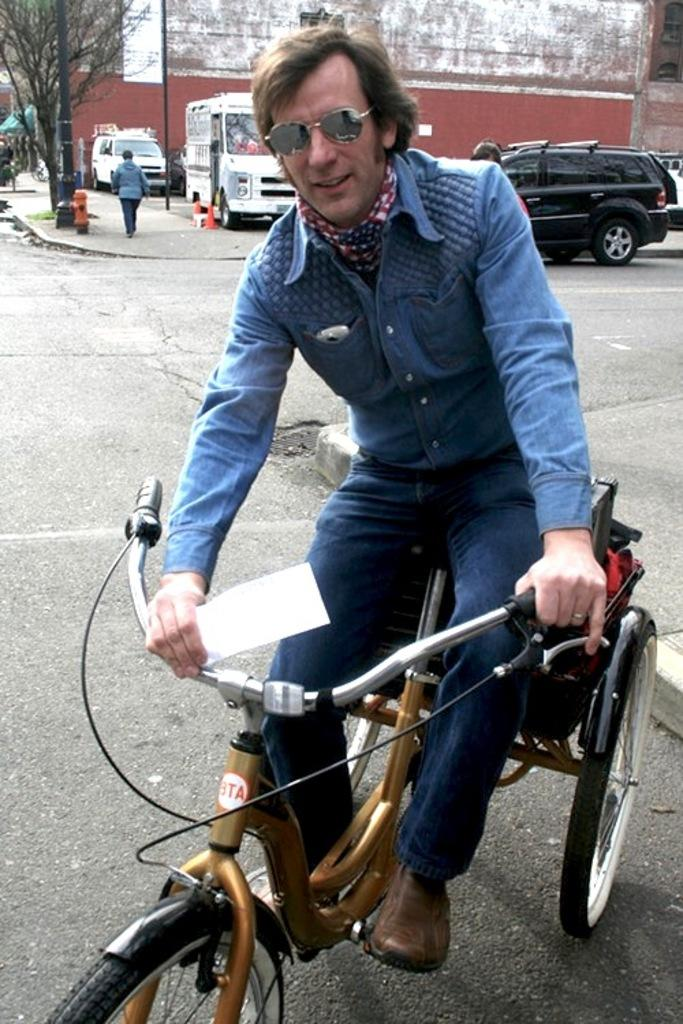What is the man in the image doing? The man is riding a tricycle in the image. What can be seen in the background of the image? There is a car, a vehicle, a traffic cone, and a tree in the background of the image. What type of fruit is hanging from the tree in the image? There is no fruit visible in the image; only a tree is mentioned in the background. 